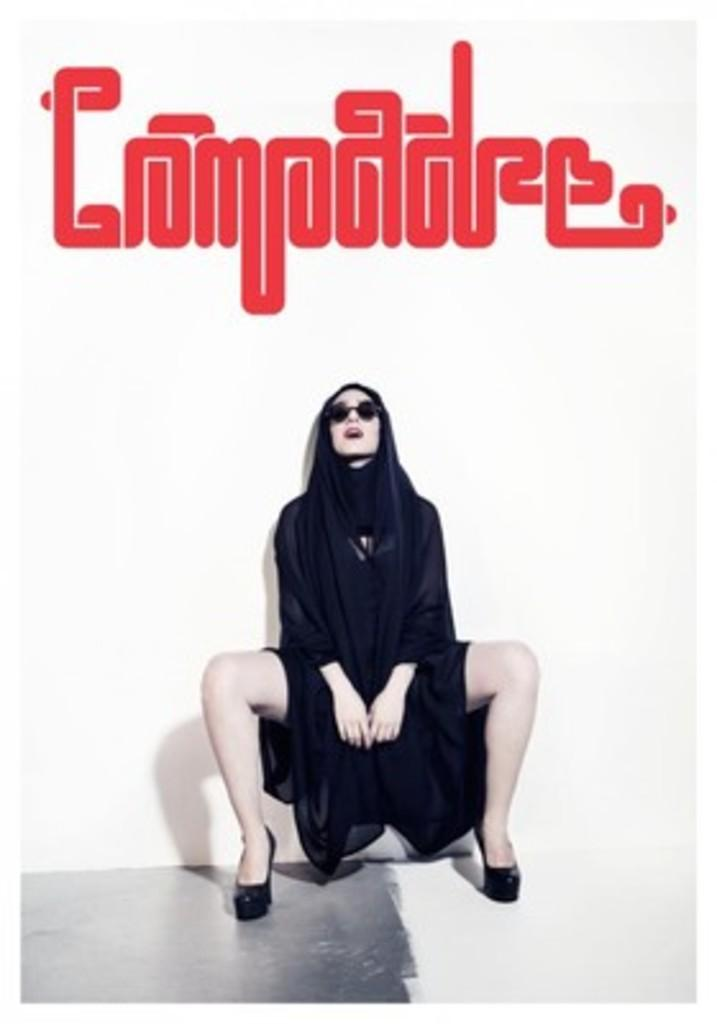Who is the main subject in the picture? There is a woman in the center of the picture. What is the woman wearing? The woman is wearing a black dress. What can be seen at the top of the image? There is some text at the top of the image. What is behind the woman in the picture? There is a wall behind the woman. What color is the wall? The wall is painted white. What type of lettuce is being used as a bun for the sandwich in the image? There is no sandwich or lettuce present in the image; it features a woman wearing a black dress with a white wall behind her. How does the taste of the image compare to that of a ripe mango? The image does not have a taste, as it is a visual representation and not a food item. 